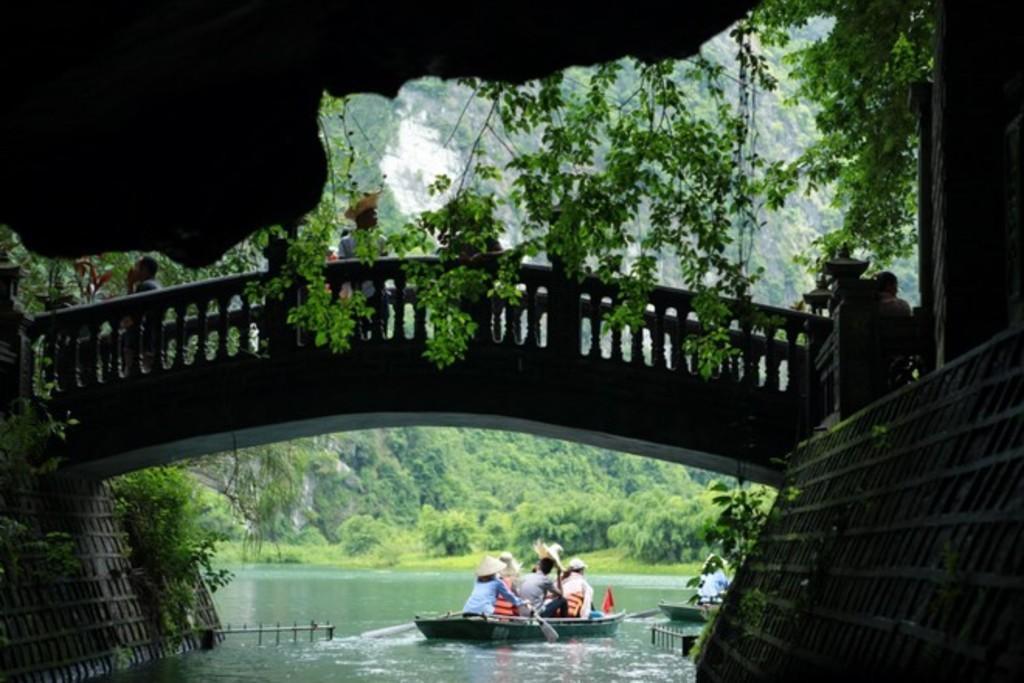In one or two sentences, can you explain what this image depicts? In this image in the center there is one bridge, on the bridge there are some persons and at the bottom there is a river. In the river there are some boats and in the books there are some people who are sitting, in the background there are some trees. On the right side and left side there are some boards and plants. 